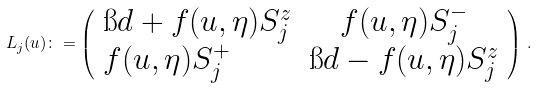<formula> <loc_0><loc_0><loc_500><loc_500>L _ { j } ( u ) \colon = \left ( \begin{array} { l c c } \i d + f ( u , \eta ) S ^ { z } _ { j } & f ( u , \eta ) S ^ { - } _ { j } \\ f ( u , \eta ) S ^ { + } _ { j } & \i d - f ( u , \eta ) S ^ { z } _ { j } \end{array} \right ) \, .</formula> 